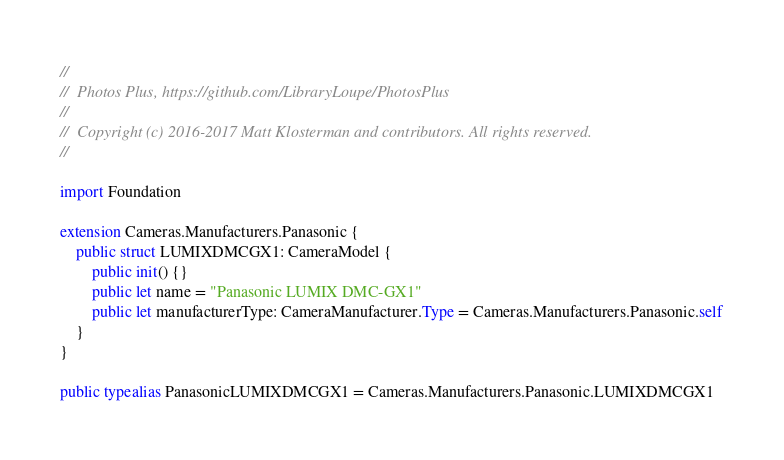<code> <loc_0><loc_0><loc_500><loc_500><_Swift_>//
//  Photos Plus, https://github.com/LibraryLoupe/PhotosPlus
//
//  Copyright (c) 2016-2017 Matt Klosterman and contributors. All rights reserved.
//

import Foundation

extension Cameras.Manufacturers.Panasonic {
    public struct LUMIXDMCGX1: CameraModel {
        public init() {}
        public let name = "Panasonic LUMIX DMC-GX1"
        public let manufacturerType: CameraManufacturer.Type = Cameras.Manufacturers.Panasonic.self
    }
}

public typealias PanasonicLUMIXDMCGX1 = Cameras.Manufacturers.Panasonic.LUMIXDMCGX1
</code> 